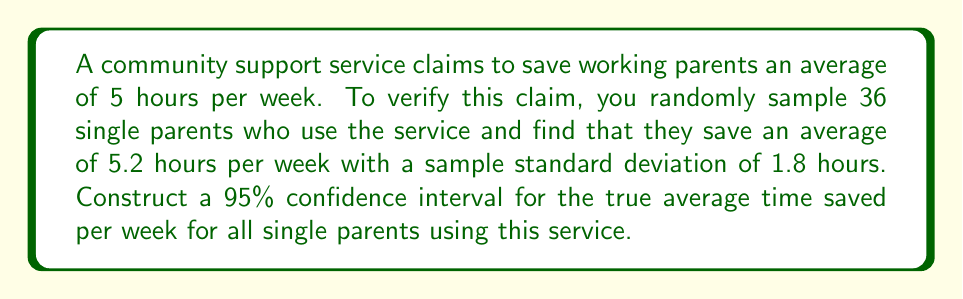Teach me how to tackle this problem. Let's approach this step-by-step:

1) We are given:
   - Sample size: $n = 36$
   - Sample mean: $\bar{x} = 5.2$ hours
   - Sample standard deviation: $s = 1.8$ hours
   - Confidence level: 95% (α = 0.05)

2) For a 95% confidence interval, we use a t-distribution with $n-1 = 35$ degrees of freedom.
   The critical value is $t_{0.025,35} = 2.030$ (from t-table or calculator)

3) The formula for the confidence interval is:

   $$\bar{x} \pm t_{\alpha/2, n-1} \cdot \frac{s}{\sqrt{n}}$$

4) Calculating the margin of error:

   $$\text{Margin of Error} = t_{\alpha/2, n-1} \cdot \frac{s}{\sqrt{n}} = 2.030 \cdot \frac{1.8}{\sqrt{36}} = 0.61$$

5) Now we can construct the confidence interval:

   $$5.2 \pm 0.61$$

6) Therefore, the 95% confidence interval is:

   $$(5.2 - 0.61, 5.2 + 0.61) = (4.59, 5.81)$$

This means we are 95% confident that the true average time saved per week for all single parents using this service is between 4.59 and 5.81 hours.
Answer: (4.59, 5.81) hours 